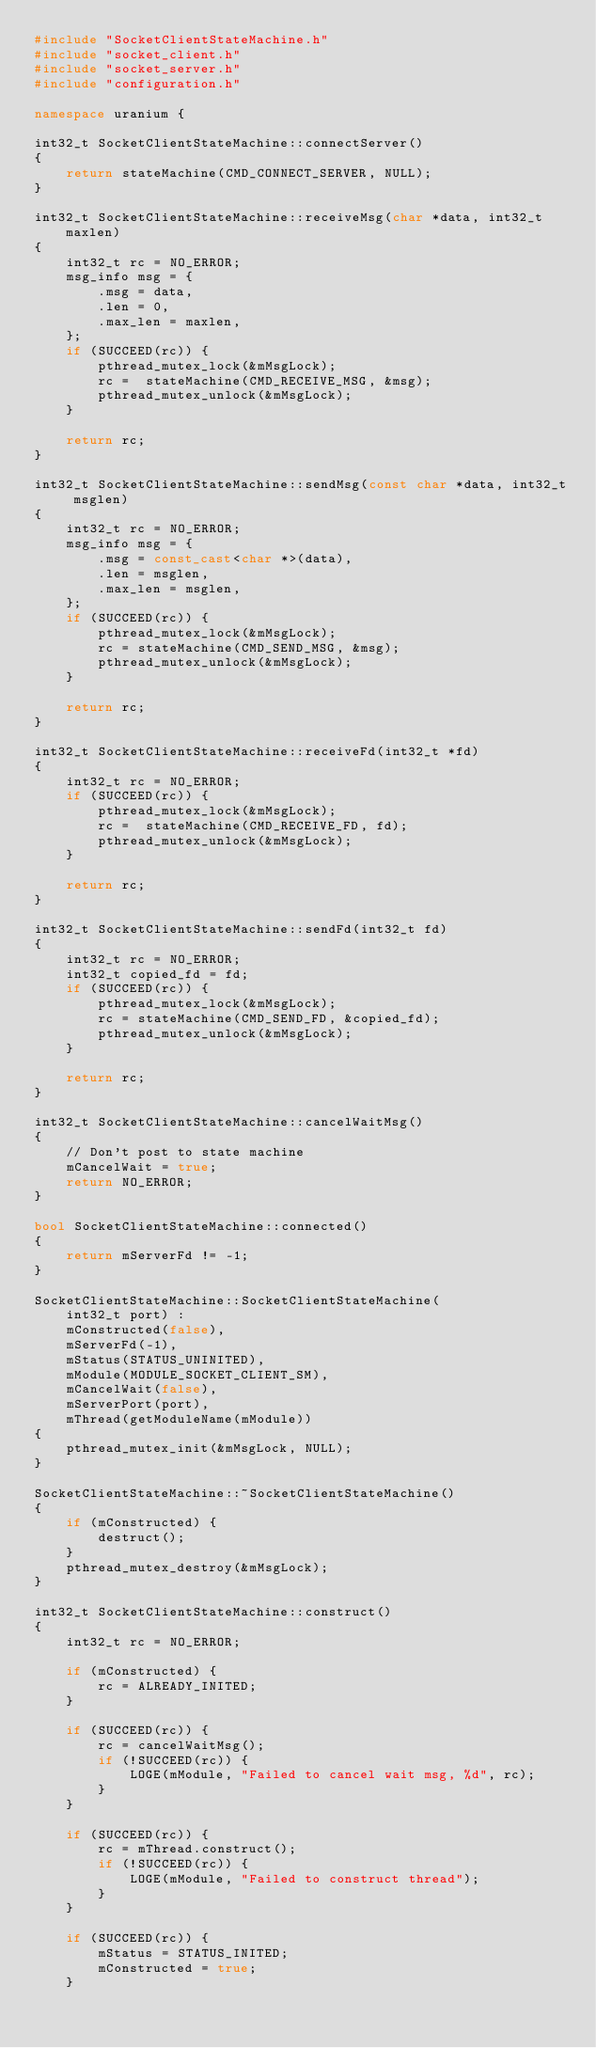Convert code to text. <code><loc_0><loc_0><loc_500><loc_500><_C++_>#include "SocketClientStateMachine.h"
#include "socket_client.h"
#include "socket_server.h"
#include "configuration.h"

namespace uranium {

int32_t SocketClientStateMachine::connectServer()
{
    return stateMachine(CMD_CONNECT_SERVER, NULL);
}

int32_t SocketClientStateMachine::receiveMsg(char *data, int32_t maxlen)
{
    int32_t rc = NO_ERROR;
    msg_info msg = {
        .msg = data,
        .len = 0,
        .max_len = maxlen,
    };
    if (SUCCEED(rc)) {
        pthread_mutex_lock(&mMsgLock);
        rc =  stateMachine(CMD_RECEIVE_MSG, &msg);
        pthread_mutex_unlock(&mMsgLock);
    }

    return rc;
}

int32_t SocketClientStateMachine::sendMsg(const char *data, int32_t msglen)
{
    int32_t rc = NO_ERROR;
    msg_info msg = {
        .msg = const_cast<char *>(data),
        .len = msglen,
        .max_len = msglen,
    };
    if (SUCCEED(rc)) {
        pthread_mutex_lock(&mMsgLock);
        rc = stateMachine(CMD_SEND_MSG, &msg);
        pthread_mutex_unlock(&mMsgLock);
    }

    return rc;
}

int32_t SocketClientStateMachine::receiveFd(int32_t *fd)
{
    int32_t rc = NO_ERROR;
    if (SUCCEED(rc)) {
        pthread_mutex_lock(&mMsgLock);
        rc =  stateMachine(CMD_RECEIVE_FD, fd);
        pthread_mutex_unlock(&mMsgLock);
    }

    return rc;
}

int32_t SocketClientStateMachine::sendFd(int32_t fd)
{
    int32_t rc = NO_ERROR;
    int32_t copied_fd = fd;
    if (SUCCEED(rc)) {
        pthread_mutex_lock(&mMsgLock);
        rc = stateMachine(CMD_SEND_FD, &copied_fd);
        pthread_mutex_unlock(&mMsgLock);
    }

    return rc;
}

int32_t SocketClientStateMachine::cancelWaitMsg()
{
    // Don't post to state machine
    mCancelWait = true;
    return NO_ERROR;
}

bool SocketClientStateMachine::connected()
{
    return mServerFd != -1;
}

SocketClientStateMachine::SocketClientStateMachine(
    int32_t port) :
    mConstructed(false),
    mServerFd(-1),
    mStatus(STATUS_UNINITED),
    mModule(MODULE_SOCKET_CLIENT_SM),
    mCancelWait(false),
    mServerPort(port),
    mThread(getModuleName(mModule))
{
    pthread_mutex_init(&mMsgLock, NULL);
}

SocketClientStateMachine::~SocketClientStateMachine()
{
    if (mConstructed) {
        destruct();
    }
    pthread_mutex_destroy(&mMsgLock);
}

int32_t SocketClientStateMachine::construct()
{
    int32_t rc = NO_ERROR;

    if (mConstructed) {
        rc = ALREADY_INITED;
    }

    if (SUCCEED(rc)) {
        rc = cancelWaitMsg();
        if (!SUCCEED(rc)) {
            LOGE(mModule, "Failed to cancel wait msg, %d", rc);
        }
    }

    if (SUCCEED(rc)) {
        rc = mThread.construct();
        if (!SUCCEED(rc)) {
            LOGE(mModule, "Failed to construct thread");
        }
    }

    if (SUCCEED(rc)) {
        mStatus = STATUS_INITED;
        mConstructed = true;
    }
</code> 